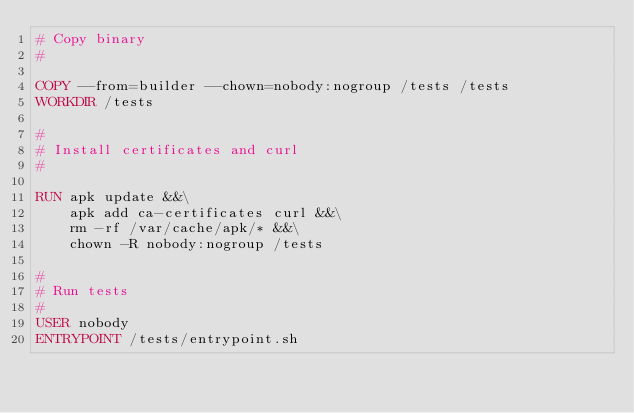<code> <loc_0><loc_0><loc_500><loc_500><_Dockerfile_># Copy binary
#

COPY --from=builder --chown=nobody:nogroup /tests /tests
WORKDIR /tests

#
# Install certificates and curl
#

RUN apk update &&\
	apk add ca-certificates curl &&\
	rm -rf /var/cache/apk/* &&\
	chown -R nobody:nogroup /tests

#
# Run tests
#
USER nobody
ENTRYPOINT /tests/entrypoint.sh
</code> 